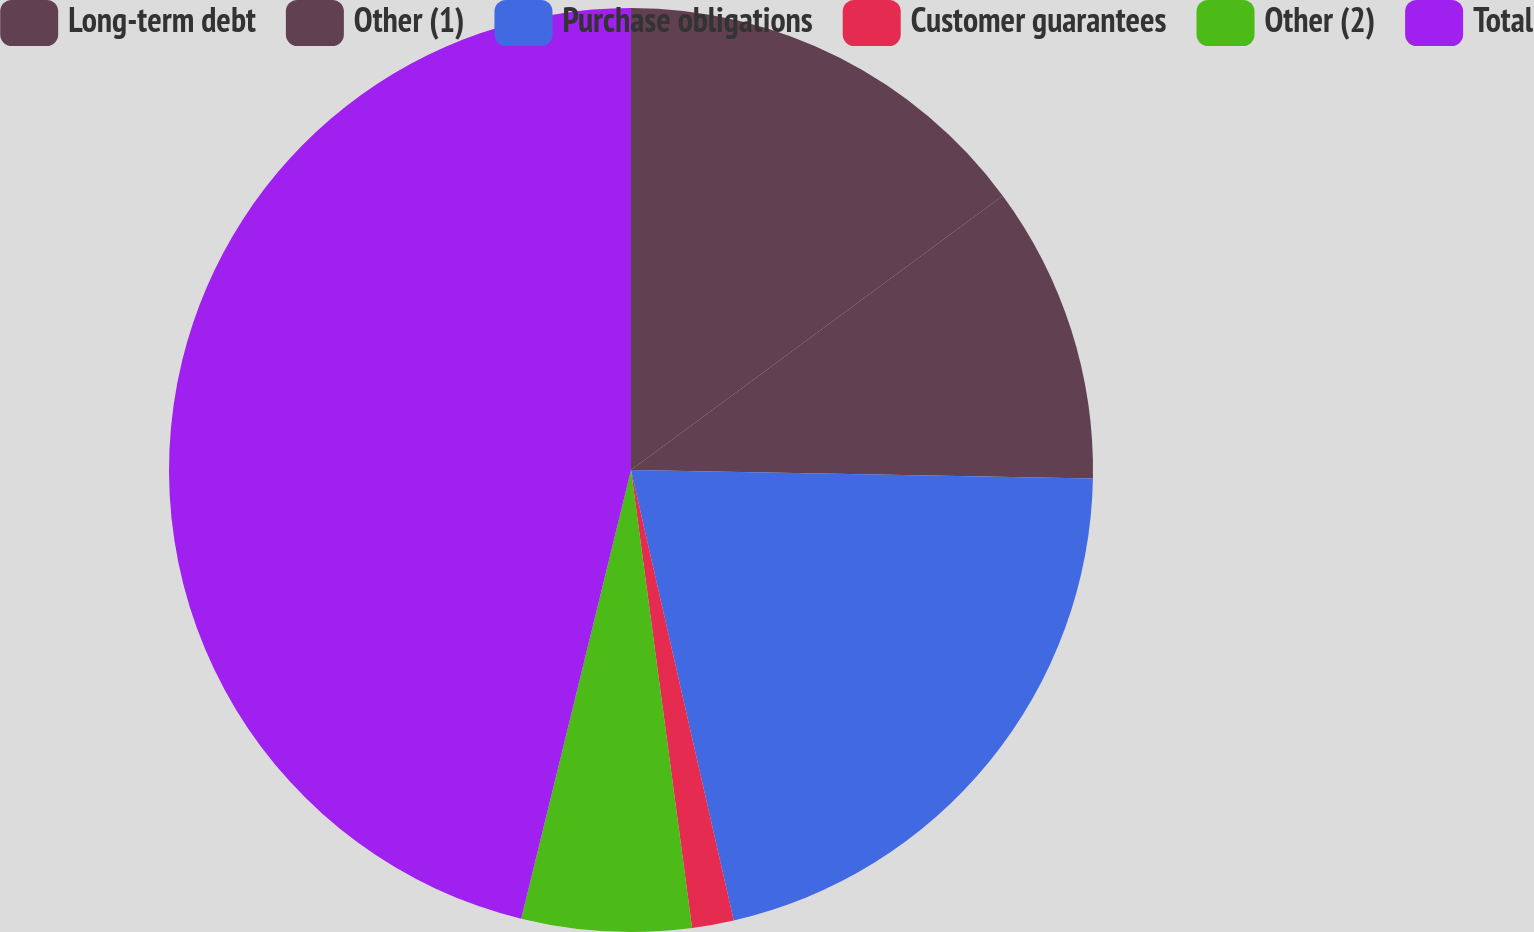<chart> <loc_0><loc_0><loc_500><loc_500><pie_chart><fcel>Long-term debt<fcel>Other (1)<fcel>Purchase obligations<fcel>Customer guarantees<fcel>Other (2)<fcel>Total<nl><fcel>14.88%<fcel>10.41%<fcel>21.14%<fcel>1.46%<fcel>5.93%<fcel>46.18%<nl></chart> 